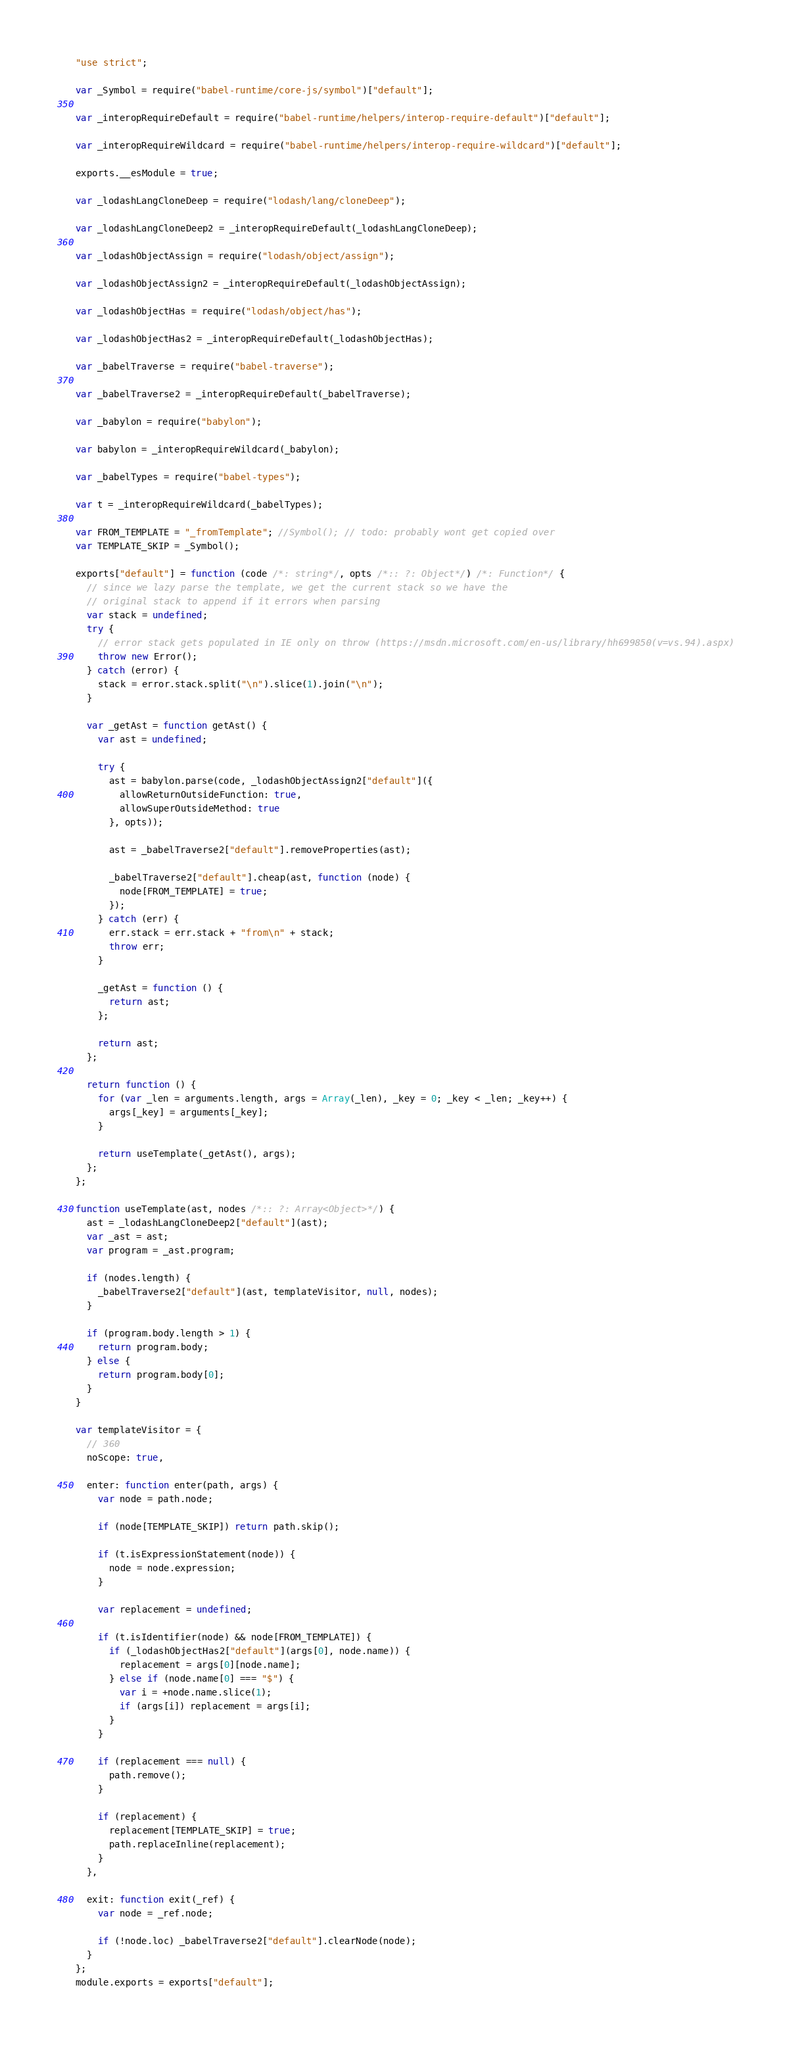Convert code to text. <code><loc_0><loc_0><loc_500><loc_500><_JavaScript_>"use strict";

var _Symbol = require("babel-runtime/core-js/symbol")["default"];

var _interopRequireDefault = require("babel-runtime/helpers/interop-require-default")["default"];

var _interopRequireWildcard = require("babel-runtime/helpers/interop-require-wildcard")["default"];

exports.__esModule = true;

var _lodashLangCloneDeep = require("lodash/lang/cloneDeep");

var _lodashLangCloneDeep2 = _interopRequireDefault(_lodashLangCloneDeep);

var _lodashObjectAssign = require("lodash/object/assign");

var _lodashObjectAssign2 = _interopRequireDefault(_lodashObjectAssign);

var _lodashObjectHas = require("lodash/object/has");

var _lodashObjectHas2 = _interopRequireDefault(_lodashObjectHas);

var _babelTraverse = require("babel-traverse");

var _babelTraverse2 = _interopRequireDefault(_babelTraverse);

var _babylon = require("babylon");

var babylon = _interopRequireWildcard(_babylon);

var _babelTypes = require("babel-types");

var t = _interopRequireWildcard(_babelTypes);

var FROM_TEMPLATE = "_fromTemplate"; //Symbol(); // todo: probably wont get copied over
var TEMPLATE_SKIP = _Symbol();

exports["default"] = function (code /*: string*/, opts /*:: ?: Object*/) /*: Function*/ {
  // since we lazy parse the template, we get the current stack so we have the
  // original stack to append if it errors when parsing
  var stack = undefined;
  try {
    // error stack gets populated in IE only on throw (https://msdn.microsoft.com/en-us/library/hh699850(v=vs.94).aspx)
    throw new Error();
  } catch (error) {
    stack = error.stack.split("\n").slice(1).join("\n");
  }

  var _getAst = function getAst() {
    var ast = undefined;

    try {
      ast = babylon.parse(code, _lodashObjectAssign2["default"]({
        allowReturnOutsideFunction: true,
        allowSuperOutsideMethod: true
      }, opts));

      ast = _babelTraverse2["default"].removeProperties(ast);

      _babelTraverse2["default"].cheap(ast, function (node) {
        node[FROM_TEMPLATE] = true;
      });
    } catch (err) {
      err.stack = err.stack + "from\n" + stack;
      throw err;
    }

    _getAst = function () {
      return ast;
    };

    return ast;
  };

  return function () {
    for (var _len = arguments.length, args = Array(_len), _key = 0; _key < _len; _key++) {
      args[_key] = arguments[_key];
    }

    return useTemplate(_getAst(), args);
  };
};

function useTemplate(ast, nodes /*:: ?: Array<Object>*/) {
  ast = _lodashLangCloneDeep2["default"](ast);
  var _ast = ast;
  var program = _ast.program;

  if (nodes.length) {
    _babelTraverse2["default"](ast, templateVisitor, null, nodes);
  }

  if (program.body.length > 1) {
    return program.body;
  } else {
    return program.body[0];
  }
}

var templateVisitor = {
  // 360
  noScope: true,

  enter: function enter(path, args) {
    var node = path.node;

    if (node[TEMPLATE_SKIP]) return path.skip();

    if (t.isExpressionStatement(node)) {
      node = node.expression;
    }

    var replacement = undefined;

    if (t.isIdentifier(node) && node[FROM_TEMPLATE]) {
      if (_lodashObjectHas2["default"](args[0], node.name)) {
        replacement = args[0][node.name];
      } else if (node.name[0] === "$") {
        var i = +node.name.slice(1);
        if (args[i]) replacement = args[i];
      }
    }

    if (replacement === null) {
      path.remove();
    }

    if (replacement) {
      replacement[TEMPLATE_SKIP] = true;
      path.replaceInline(replacement);
    }
  },

  exit: function exit(_ref) {
    var node = _ref.node;

    if (!node.loc) _babelTraverse2["default"].clearNode(node);
  }
};
module.exports = exports["default"];</code> 